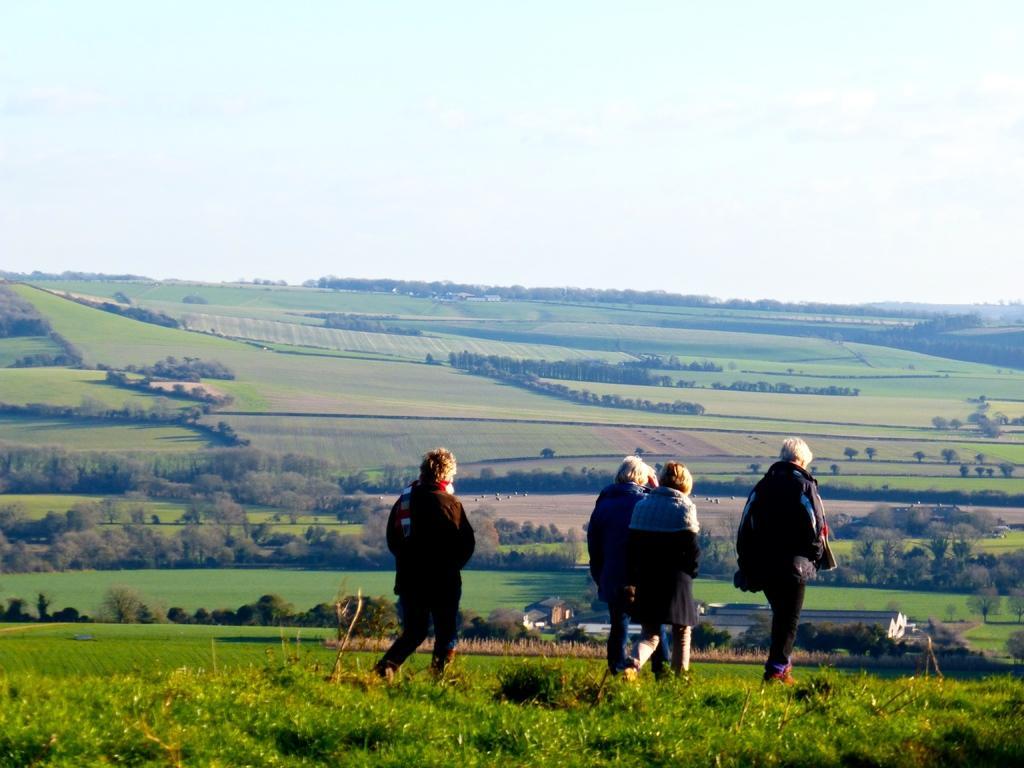Please provide a concise description of this image. This picture shows few people walking and they wore coats and we see grass on the ground and trees and a cloudy Sky. 